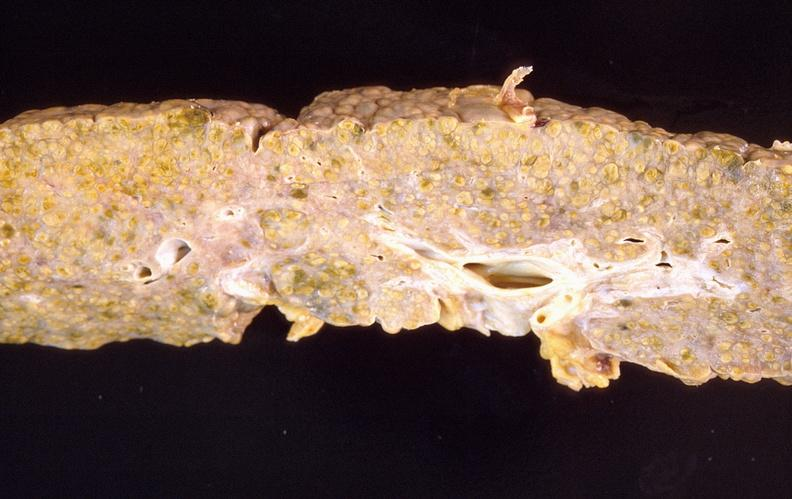s hepatobiliary present?
Answer the question using a single word or phrase. Yes 